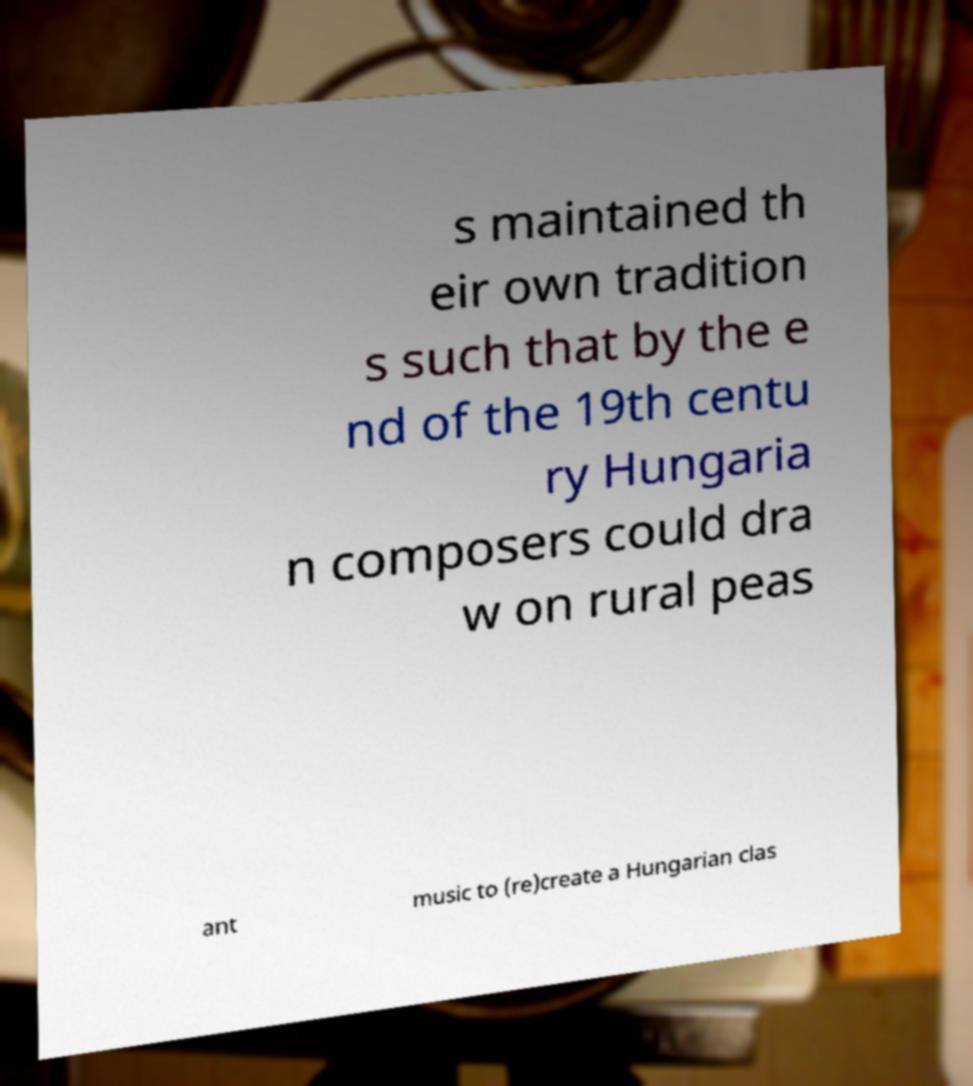Please read and relay the text visible in this image. What does it say? s maintained th eir own tradition s such that by the e nd of the 19th centu ry Hungaria n composers could dra w on rural peas ant music to (re)create a Hungarian clas 